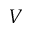<formula> <loc_0><loc_0><loc_500><loc_500>V</formula> 